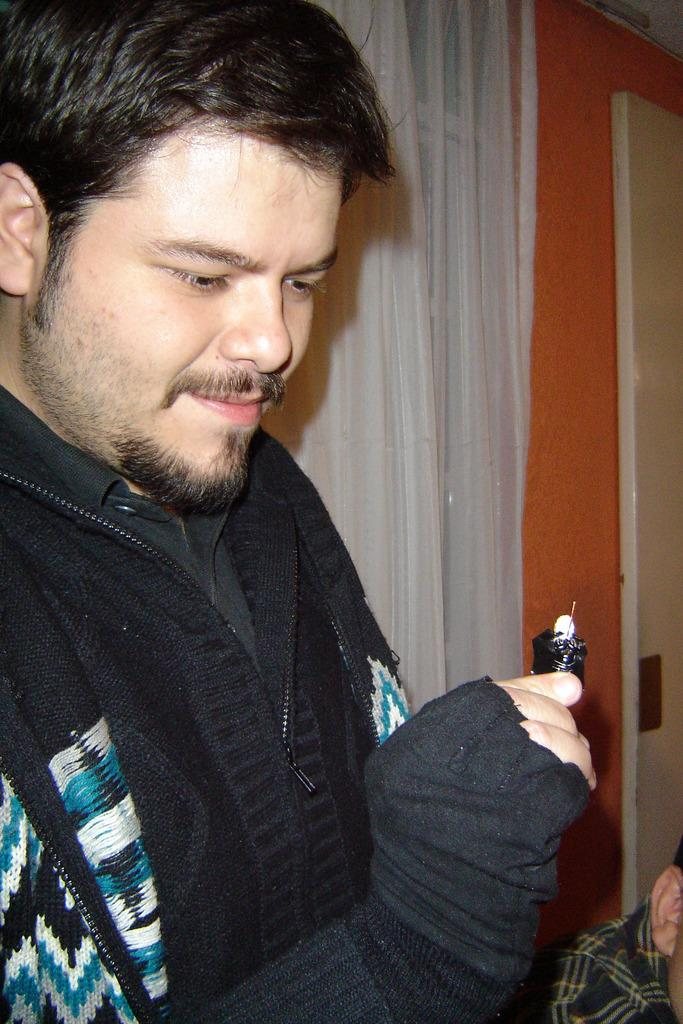What is the man holding in his hand in the image? There is a man holding an item in his hand in the image. Can you describe the other person in the image? There is another man sitting beside the first man. What can be seen in the background of the image? There is a wall in the background of the image. Is there any window treatment visible in the image? Yes, there is a curtain associated with the wall. What type of sidewalk can be seen in the image? There is no sidewalk present in the image. How does the heart rate of the man holding the item compare to the other man's heart rate in the image? There is no information about the heart rates of the men in the image, so it cannot be determined. 